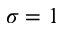<formula> <loc_0><loc_0><loc_500><loc_500>\sigma = 1</formula> 